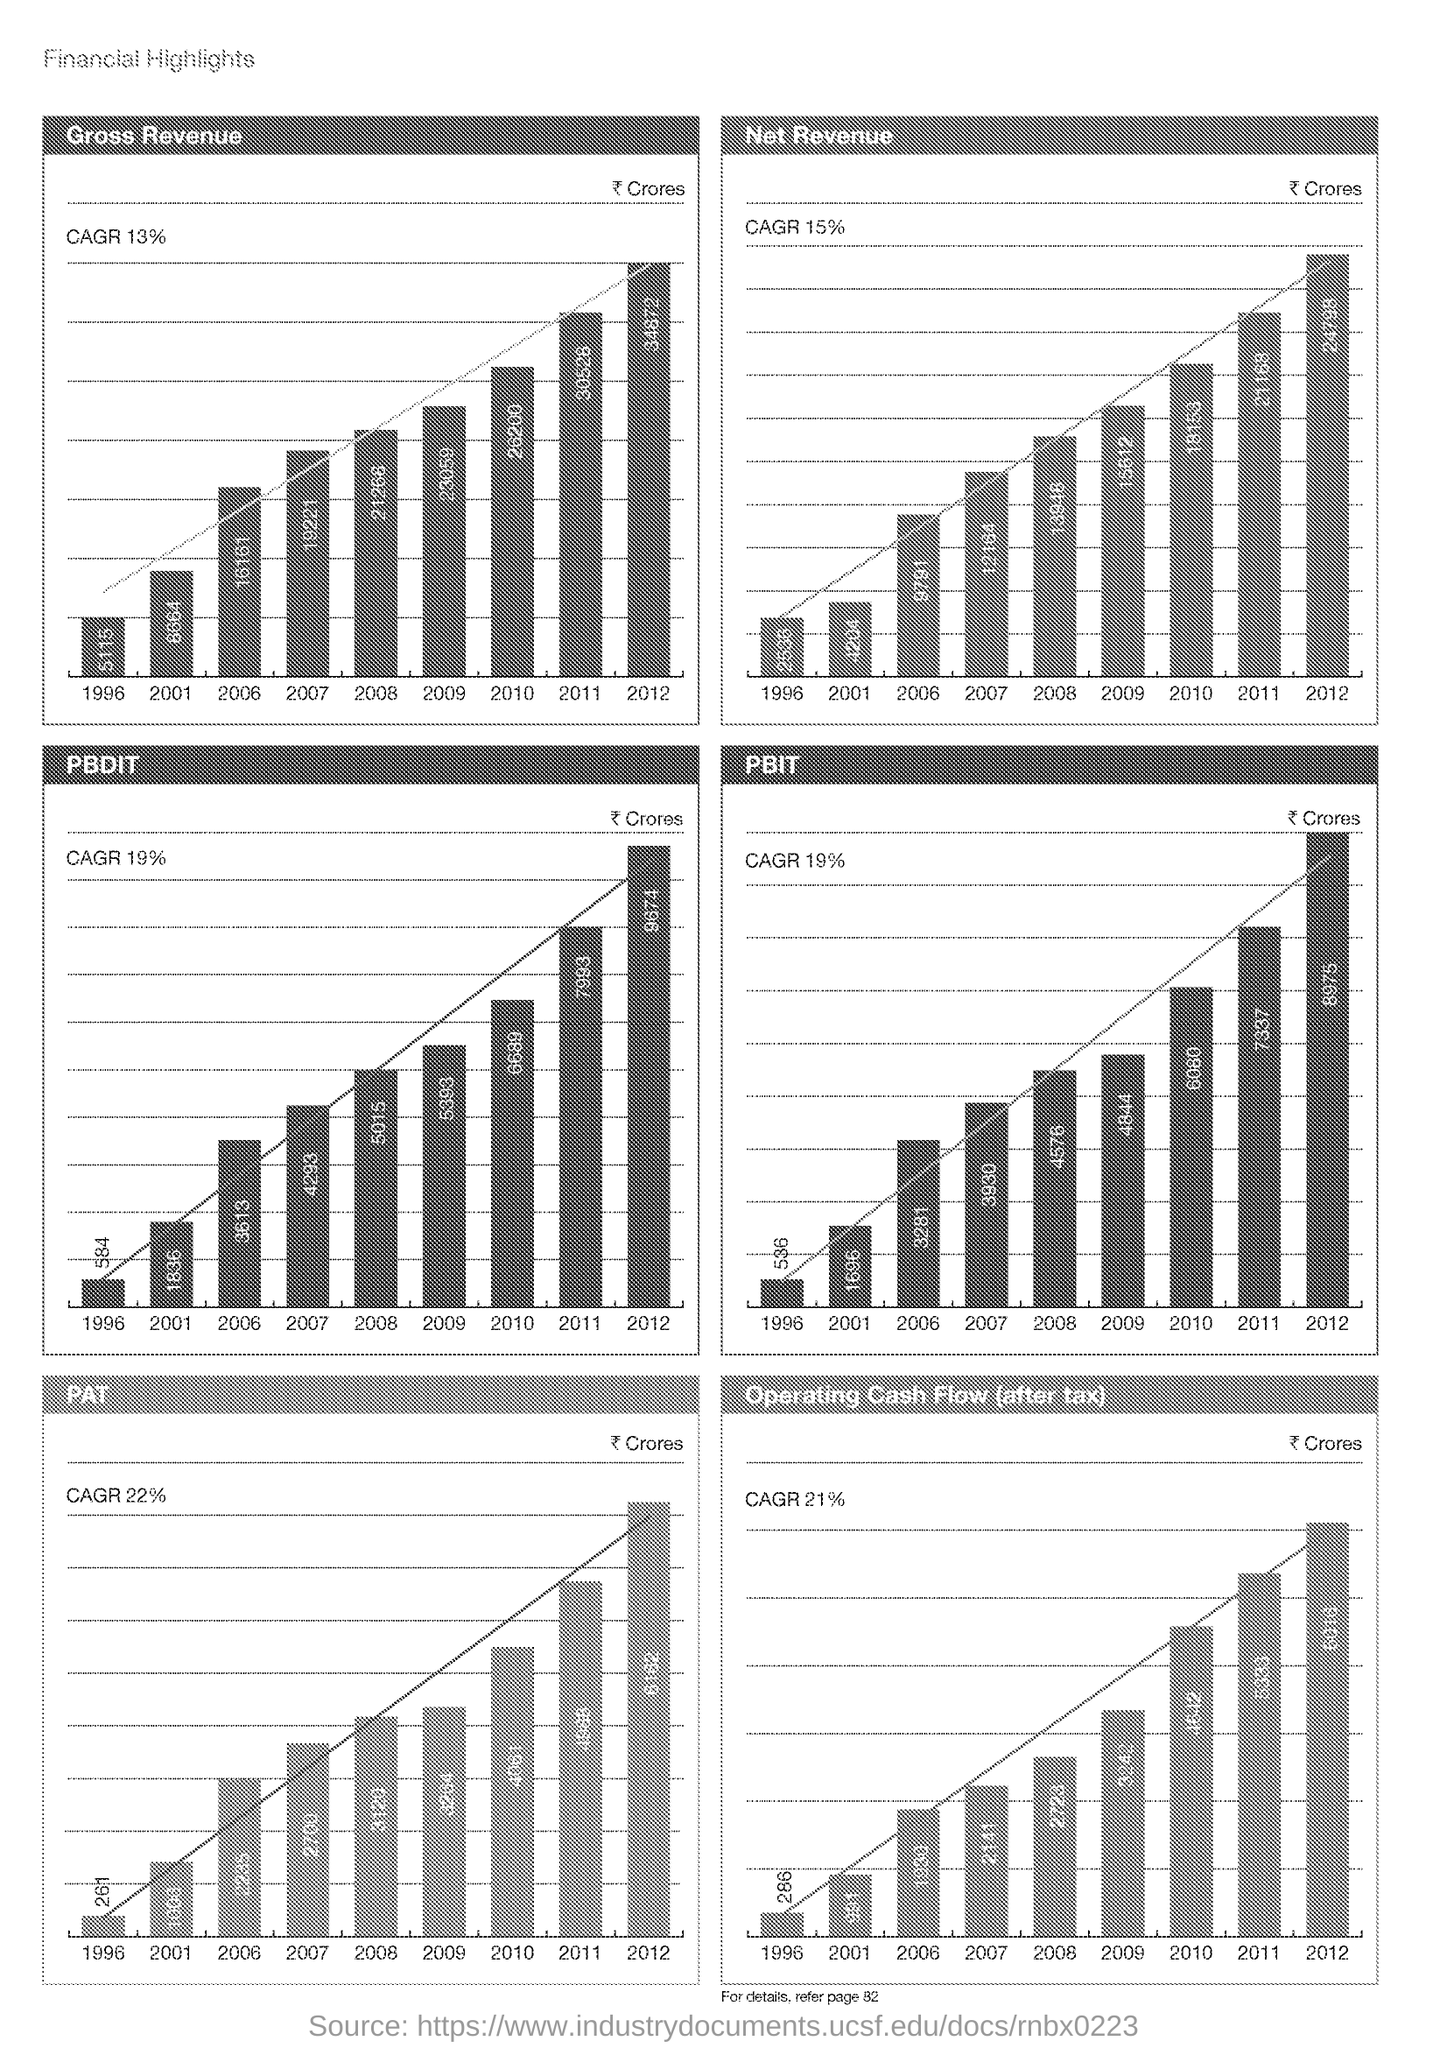Give some essential details in this illustration. The percentage of gross revenue is CAGR 13%. 